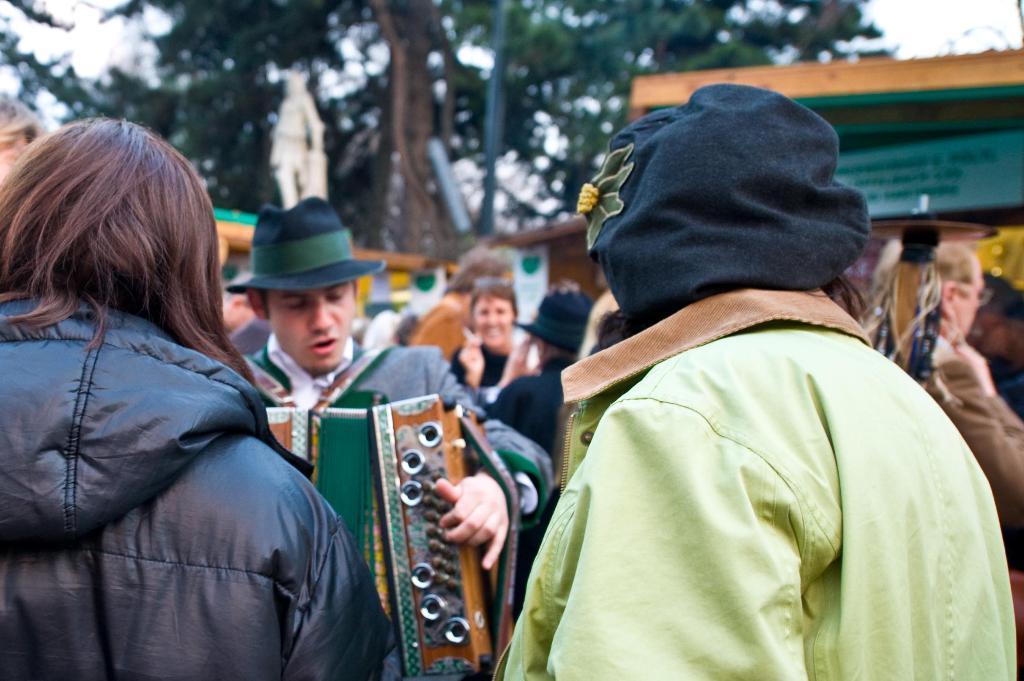How would you summarize this image in a sentence or two? In this image there are two persons in the middle. The person on the right side is wearing the black color mask. In front of him there is a man who is playing the saxophone. In the background there are so many people who are standing on the floor. Behind them there is a tree. On the right side there is a building. 